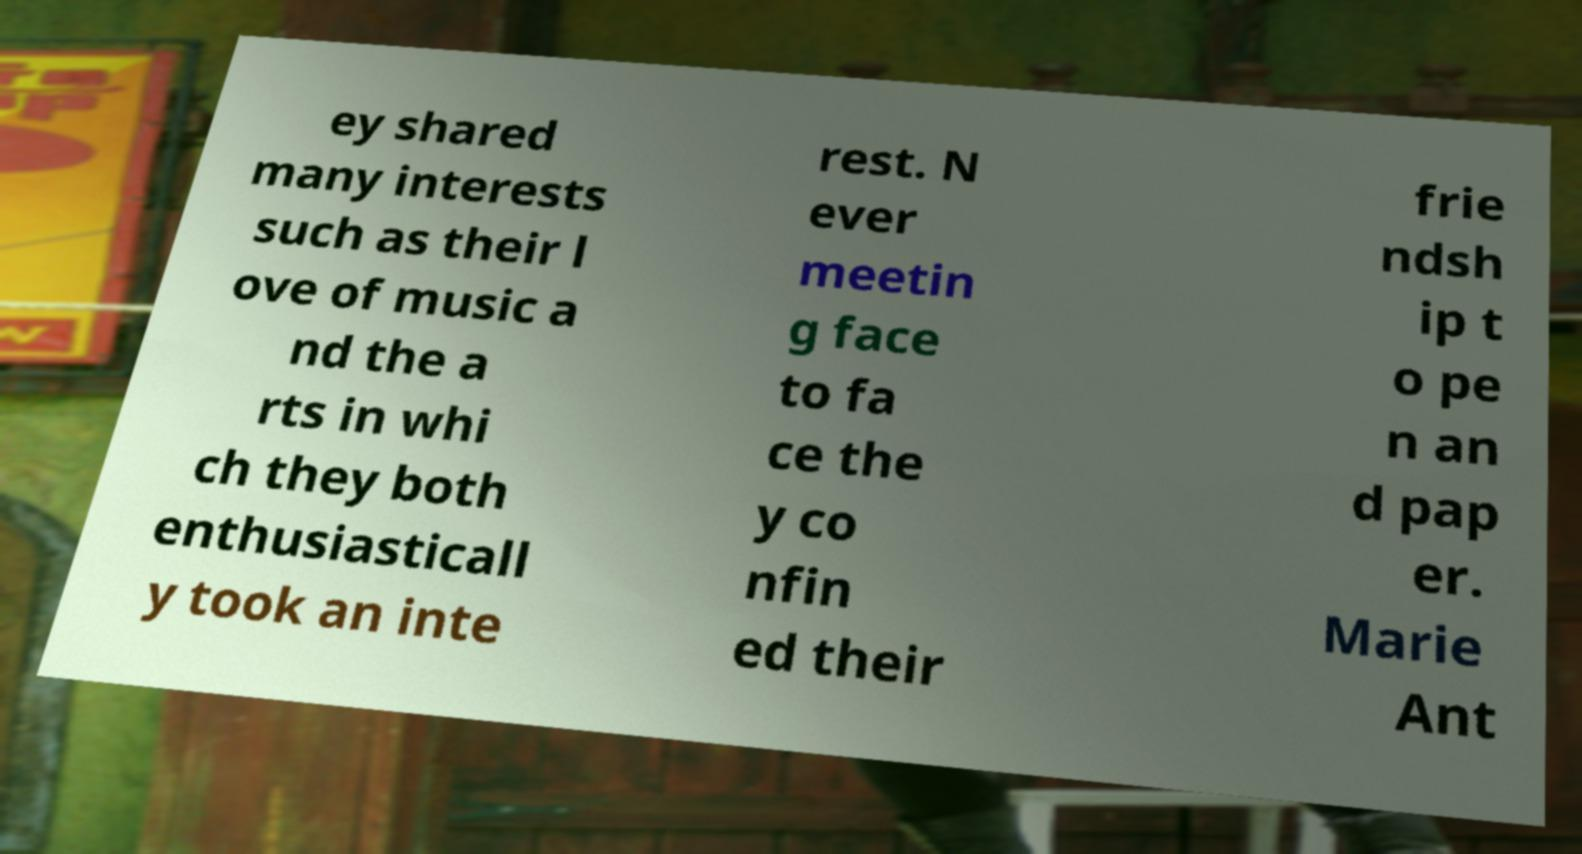What messages or text are displayed in this image? I need them in a readable, typed format. ey shared many interests such as their l ove of music a nd the a rts in whi ch they both enthusiasticall y took an inte rest. N ever meetin g face to fa ce the y co nfin ed their frie ndsh ip t o pe n an d pap er. Marie Ant 